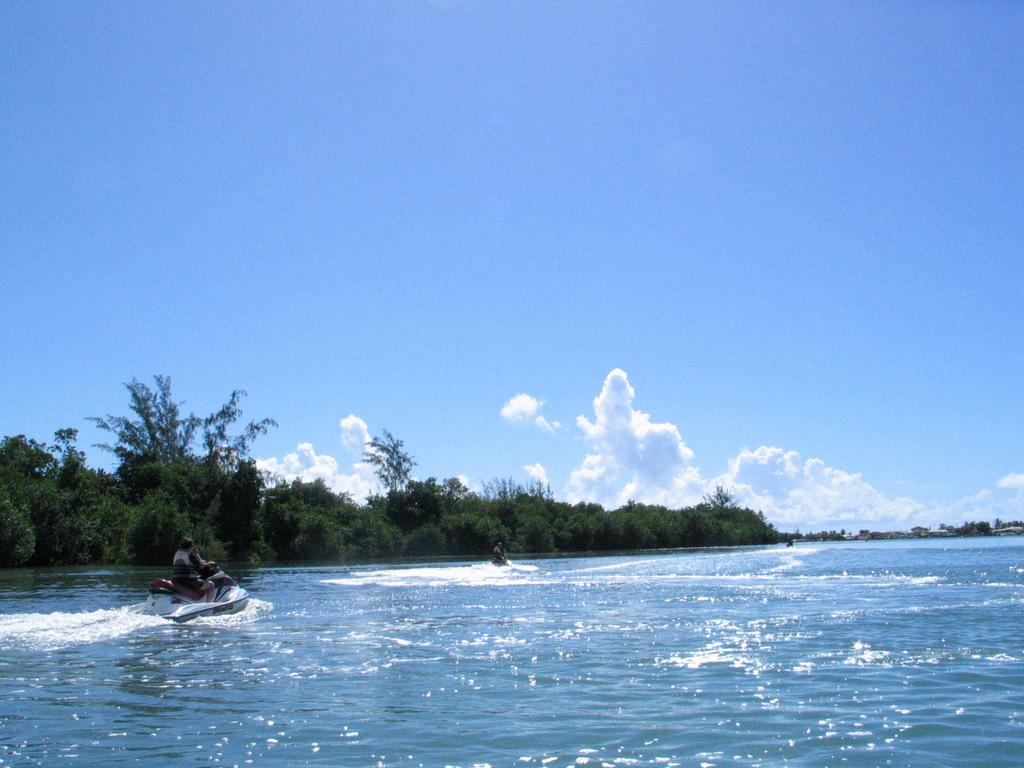How many people are in the image? There are two people in the image. What are the people doing in the image? The people are riding water scooters. Where are the water scooters located? The water scooters are on the water. What can be seen in front of the people? There are trees in front of the people. What is visible in the sky in the background of the image? There are clouds visible in the sky in the background of the image. What type of vest is the person wearing while riding the faucet in the image? There is no faucet or vest present in the image; the people are riding water scooters on the water. 